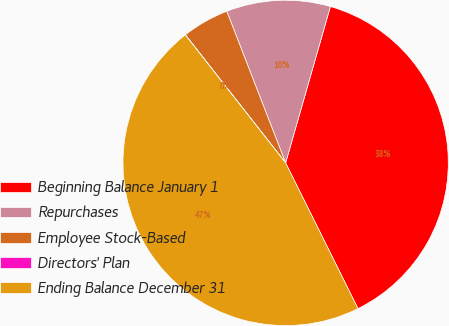<chart> <loc_0><loc_0><loc_500><loc_500><pie_chart><fcel>Beginning Balance January 1<fcel>Repurchases<fcel>Employee Stock-Based<fcel>Directors' Plan<fcel>Ending Balance December 31<nl><fcel>38.23%<fcel>10.33%<fcel>4.68%<fcel>0.01%<fcel>46.76%<nl></chart> 